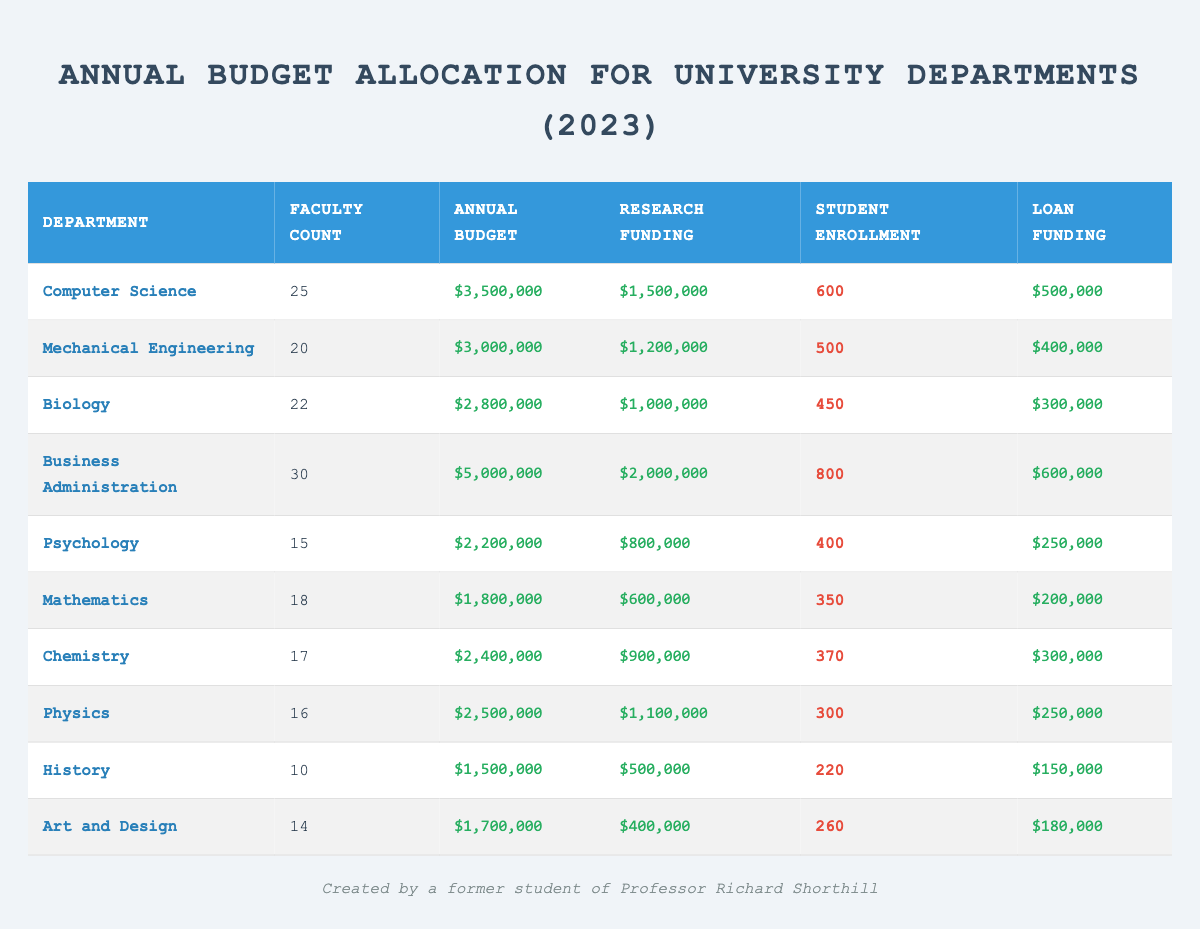What is the annual budget for the Computer Science department? The annual budget for the Computer Science department is listed directly in the table. It shows $3,500,000 for the department.
Answer: $3,500,000 How many faculty members are in the Business Administration department? The table indicates the number of faculty members in the Business Administration department, which is 30.
Answer: 30 What is the total annual budget allocated for all departments? To find the total, sum all the annual budgets: (3,500,000 + 3,000,000 + 2,800,000 + 5,000,000 + 2,200,000 + 1,800,000 + 2,400,000 + 2,500,000 + 1,500,000 + 1,700,000) = 27,100,000.
Answer: $27,100,000 Which department has the highest student enrollment? By comparing the student enrollment values across departments, Business Administration has the highest enrollment at 800 students.
Answer: Business Administration What is the average research funding across all departments? Calculate the total research funding by summing these values: (1,500,000 + 1,200,000 + 1,000,000 + 2,000,000 + 800,000 + 600,000 + 900,000 + 1,100,000 + 500,000 + 400,000) = 10,900,000. There are ten departments, so the average is 10,900,000 / 10 = 1,090,000.
Answer: $1,090,000 Does the Psychology department receive more annual budget than the Chemistry department? Comparing the annual budgets, Psychology has $2,200,000 and Chemistry has $2,400,000. Since 2,200,000 is less than 2,400,000, the answer is no.
Answer: No What percentage of the total budget is allocated to the Computer Science department? The budget for Computer Science is $3,500,000, and the total budget is $27,100,000. To find the percentage: (3,500,000 / 27,100,000) * 100 = approximately 12.92%.
Answer: 12.92% How much loan funding does the Mechanical Engineering department receive compared to the Physics department? Mechanical Engineering has loan funding of $400,000, while Physics has $250,000. The difference is $400,000 - $250,000 = $150,000.
Answer: $150,000 Which department has the lowest faculty count? Upon examining the faculty counts provided in the table, History has the lowest count with 10 faculty members.
Answer: History What is the total student enrollment for all departments combined? Sum up the student enrollment figures: (600 + 500 + 450 + 800 + 400 + 350 + 370 + 300 + 220 + 260) = 4,180.
Answer: 4,180 